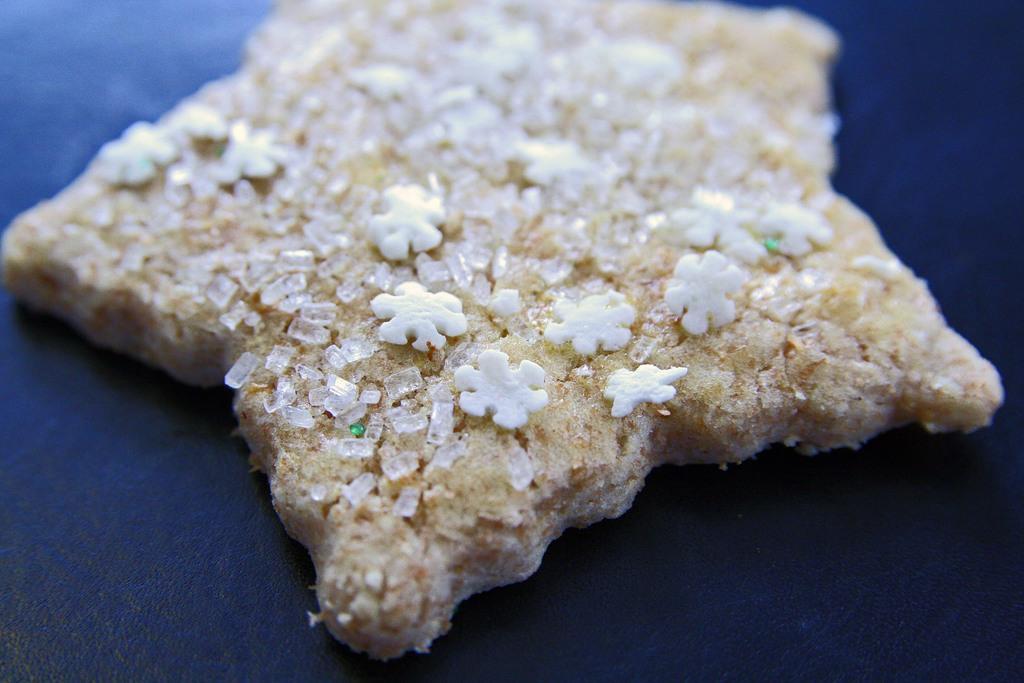Describe this image in one or two sentences. In this picture we can see food on the surface. 